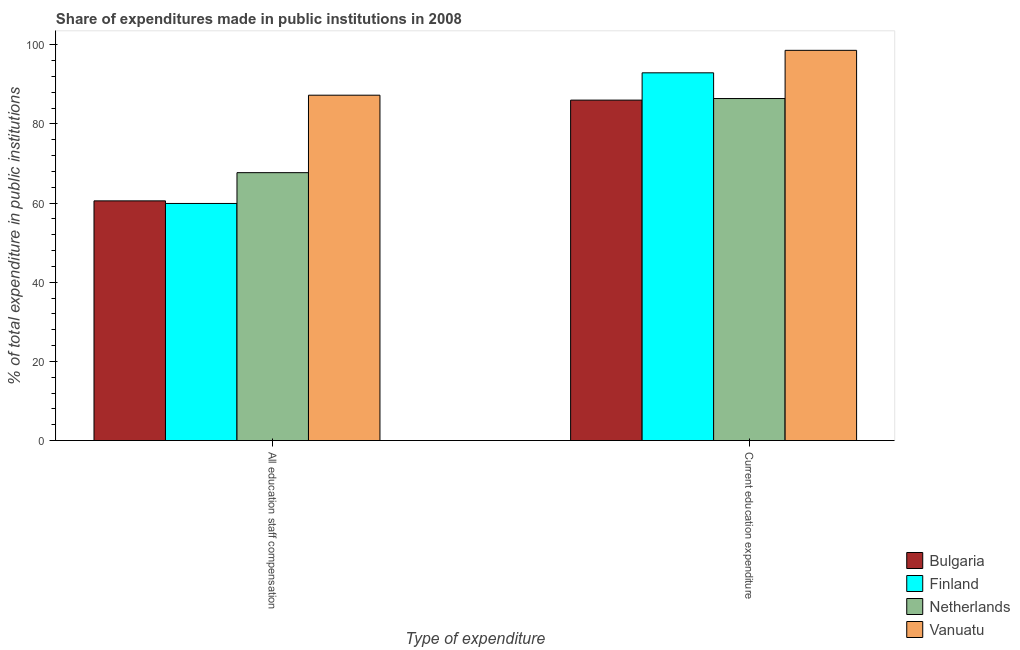How many groups of bars are there?
Ensure brevity in your answer.  2. Are the number of bars per tick equal to the number of legend labels?
Your response must be concise. Yes. How many bars are there on the 1st tick from the left?
Offer a very short reply. 4. How many bars are there on the 1st tick from the right?
Your answer should be compact. 4. What is the label of the 1st group of bars from the left?
Make the answer very short. All education staff compensation. What is the expenditure in staff compensation in Finland?
Provide a succinct answer. 59.91. Across all countries, what is the maximum expenditure in staff compensation?
Ensure brevity in your answer.  87.27. Across all countries, what is the minimum expenditure in staff compensation?
Keep it short and to the point. 59.91. In which country was the expenditure in education maximum?
Your answer should be very brief. Vanuatu. In which country was the expenditure in education minimum?
Make the answer very short. Bulgaria. What is the total expenditure in education in the graph?
Provide a succinct answer. 363.99. What is the difference between the expenditure in education in Bulgaria and that in Netherlands?
Provide a short and direct response. -0.4. What is the difference between the expenditure in staff compensation in Finland and the expenditure in education in Vanuatu?
Keep it short and to the point. -38.69. What is the average expenditure in staff compensation per country?
Your response must be concise. 68.86. What is the difference between the expenditure in education and expenditure in staff compensation in Netherlands?
Make the answer very short. 18.73. What is the ratio of the expenditure in staff compensation in Netherlands to that in Finland?
Provide a succinct answer. 1.13. What does the 3rd bar from the left in All education staff compensation represents?
Offer a terse response. Netherlands. Are all the bars in the graph horizontal?
Provide a short and direct response. No. How many countries are there in the graph?
Your answer should be compact. 4. Are the values on the major ticks of Y-axis written in scientific E-notation?
Offer a very short reply. No. Does the graph contain any zero values?
Your response must be concise. No. Does the graph contain grids?
Offer a terse response. No. Where does the legend appear in the graph?
Make the answer very short. Bottom right. How many legend labels are there?
Keep it short and to the point. 4. How are the legend labels stacked?
Keep it short and to the point. Vertical. What is the title of the graph?
Your answer should be compact. Share of expenditures made in public institutions in 2008. Does "Latvia" appear as one of the legend labels in the graph?
Offer a terse response. No. What is the label or title of the X-axis?
Provide a short and direct response. Type of expenditure. What is the label or title of the Y-axis?
Provide a short and direct response. % of total expenditure in public institutions. What is the % of total expenditure in public institutions of Bulgaria in All education staff compensation?
Provide a succinct answer. 60.57. What is the % of total expenditure in public institutions in Finland in All education staff compensation?
Your answer should be very brief. 59.91. What is the % of total expenditure in public institutions of Netherlands in All education staff compensation?
Your answer should be very brief. 67.7. What is the % of total expenditure in public institutions in Vanuatu in All education staff compensation?
Keep it short and to the point. 87.27. What is the % of total expenditure in public institutions of Bulgaria in Current education expenditure?
Your answer should be compact. 86.03. What is the % of total expenditure in public institutions of Finland in Current education expenditure?
Give a very brief answer. 92.93. What is the % of total expenditure in public institutions in Netherlands in Current education expenditure?
Ensure brevity in your answer.  86.43. What is the % of total expenditure in public institutions of Vanuatu in Current education expenditure?
Give a very brief answer. 98.61. Across all Type of expenditure, what is the maximum % of total expenditure in public institutions in Bulgaria?
Give a very brief answer. 86.03. Across all Type of expenditure, what is the maximum % of total expenditure in public institutions in Finland?
Provide a short and direct response. 92.93. Across all Type of expenditure, what is the maximum % of total expenditure in public institutions of Netherlands?
Keep it short and to the point. 86.43. Across all Type of expenditure, what is the maximum % of total expenditure in public institutions of Vanuatu?
Keep it short and to the point. 98.61. Across all Type of expenditure, what is the minimum % of total expenditure in public institutions of Bulgaria?
Make the answer very short. 60.57. Across all Type of expenditure, what is the minimum % of total expenditure in public institutions of Finland?
Provide a short and direct response. 59.91. Across all Type of expenditure, what is the minimum % of total expenditure in public institutions in Netherlands?
Offer a very short reply. 67.7. Across all Type of expenditure, what is the minimum % of total expenditure in public institutions of Vanuatu?
Your answer should be compact. 87.27. What is the total % of total expenditure in public institutions in Bulgaria in the graph?
Your answer should be compact. 146.6. What is the total % of total expenditure in public institutions in Finland in the graph?
Keep it short and to the point. 152.84. What is the total % of total expenditure in public institutions of Netherlands in the graph?
Provide a short and direct response. 154.13. What is the total % of total expenditure in public institutions in Vanuatu in the graph?
Make the answer very short. 185.88. What is the difference between the % of total expenditure in public institutions in Bulgaria in All education staff compensation and that in Current education expenditure?
Your answer should be very brief. -25.46. What is the difference between the % of total expenditure in public institutions in Finland in All education staff compensation and that in Current education expenditure?
Keep it short and to the point. -33.01. What is the difference between the % of total expenditure in public institutions in Netherlands in All education staff compensation and that in Current education expenditure?
Offer a terse response. -18.73. What is the difference between the % of total expenditure in public institutions of Vanuatu in All education staff compensation and that in Current education expenditure?
Keep it short and to the point. -11.34. What is the difference between the % of total expenditure in public institutions of Bulgaria in All education staff compensation and the % of total expenditure in public institutions of Finland in Current education expenditure?
Your response must be concise. -32.36. What is the difference between the % of total expenditure in public institutions of Bulgaria in All education staff compensation and the % of total expenditure in public institutions of Netherlands in Current education expenditure?
Keep it short and to the point. -25.86. What is the difference between the % of total expenditure in public institutions in Bulgaria in All education staff compensation and the % of total expenditure in public institutions in Vanuatu in Current education expenditure?
Provide a short and direct response. -38.04. What is the difference between the % of total expenditure in public institutions of Finland in All education staff compensation and the % of total expenditure in public institutions of Netherlands in Current education expenditure?
Provide a short and direct response. -26.51. What is the difference between the % of total expenditure in public institutions of Finland in All education staff compensation and the % of total expenditure in public institutions of Vanuatu in Current education expenditure?
Provide a succinct answer. -38.69. What is the difference between the % of total expenditure in public institutions of Netherlands in All education staff compensation and the % of total expenditure in public institutions of Vanuatu in Current education expenditure?
Offer a terse response. -30.91. What is the average % of total expenditure in public institutions in Bulgaria per Type of expenditure?
Your answer should be compact. 73.3. What is the average % of total expenditure in public institutions in Finland per Type of expenditure?
Give a very brief answer. 76.42. What is the average % of total expenditure in public institutions of Netherlands per Type of expenditure?
Your answer should be very brief. 77.06. What is the average % of total expenditure in public institutions of Vanuatu per Type of expenditure?
Your answer should be compact. 92.94. What is the difference between the % of total expenditure in public institutions in Bulgaria and % of total expenditure in public institutions in Finland in All education staff compensation?
Offer a very short reply. 0.66. What is the difference between the % of total expenditure in public institutions in Bulgaria and % of total expenditure in public institutions in Netherlands in All education staff compensation?
Make the answer very short. -7.13. What is the difference between the % of total expenditure in public institutions of Bulgaria and % of total expenditure in public institutions of Vanuatu in All education staff compensation?
Provide a short and direct response. -26.7. What is the difference between the % of total expenditure in public institutions in Finland and % of total expenditure in public institutions in Netherlands in All education staff compensation?
Provide a succinct answer. -7.79. What is the difference between the % of total expenditure in public institutions of Finland and % of total expenditure in public institutions of Vanuatu in All education staff compensation?
Offer a very short reply. -27.36. What is the difference between the % of total expenditure in public institutions in Netherlands and % of total expenditure in public institutions in Vanuatu in All education staff compensation?
Keep it short and to the point. -19.57. What is the difference between the % of total expenditure in public institutions in Bulgaria and % of total expenditure in public institutions in Finland in Current education expenditure?
Provide a succinct answer. -6.9. What is the difference between the % of total expenditure in public institutions of Bulgaria and % of total expenditure in public institutions of Netherlands in Current education expenditure?
Your answer should be compact. -0.4. What is the difference between the % of total expenditure in public institutions of Bulgaria and % of total expenditure in public institutions of Vanuatu in Current education expenditure?
Give a very brief answer. -12.58. What is the difference between the % of total expenditure in public institutions of Finland and % of total expenditure in public institutions of Netherlands in Current education expenditure?
Your answer should be very brief. 6.5. What is the difference between the % of total expenditure in public institutions of Finland and % of total expenditure in public institutions of Vanuatu in Current education expenditure?
Provide a succinct answer. -5.68. What is the difference between the % of total expenditure in public institutions of Netherlands and % of total expenditure in public institutions of Vanuatu in Current education expenditure?
Keep it short and to the point. -12.18. What is the ratio of the % of total expenditure in public institutions of Bulgaria in All education staff compensation to that in Current education expenditure?
Keep it short and to the point. 0.7. What is the ratio of the % of total expenditure in public institutions of Finland in All education staff compensation to that in Current education expenditure?
Ensure brevity in your answer.  0.64. What is the ratio of the % of total expenditure in public institutions in Netherlands in All education staff compensation to that in Current education expenditure?
Offer a terse response. 0.78. What is the ratio of the % of total expenditure in public institutions in Vanuatu in All education staff compensation to that in Current education expenditure?
Provide a short and direct response. 0.89. What is the difference between the highest and the second highest % of total expenditure in public institutions in Bulgaria?
Offer a very short reply. 25.46. What is the difference between the highest and the second highest % of total expenditure in public institutions of Finland?
Your answer should be very brief. 33.01. What is the difference between the highest and the second highest % of total expenditure in public institutions in Netherlands?
Provide a succinct answer. 18.73. What is the difference between the highest and the second highest % of total expenditure in public institutions in Vanuatu?
Your response must be concise. 11.34. What is the difference between the highest and the lowest % of total expenditure in public institutions of Bulgaria?
Your answer should be compact. 25.46. What is the difference between the highest and the lowest % of total expenditure in public institutions of Finland?
Keep it short and to the point. 33.01. What is the difference between the highest and the lowest % of total expenditure in public institutions of Netherlands?
Offer a very short reply. 18.73. What is the difference between the highest and the lowest % of total expenditure in public institutions of Vanuatu?
Offer a terse response. 11.34. 